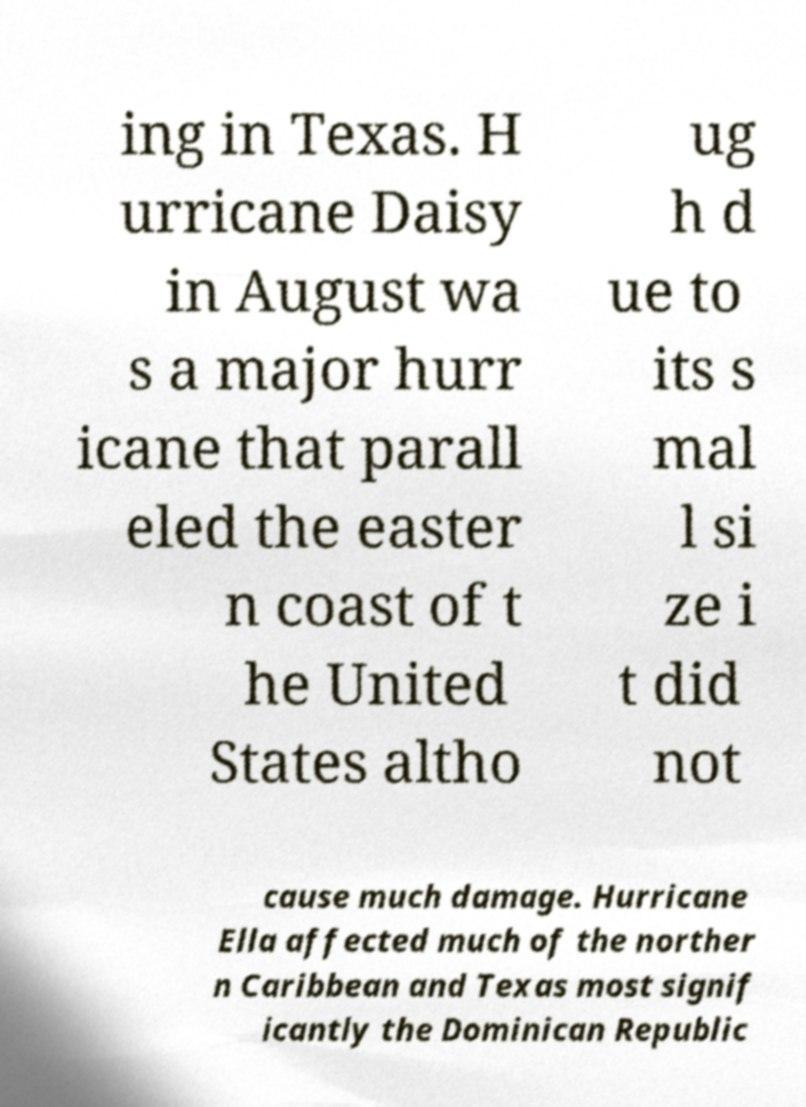There's text embedded in this image that I need extracted. Can you transcribe it verbatim? ing in Texas. H urricane Daisy in August wa s a major hurr icane that parall eled the easter n coast of t he United States altho ug h d ue to its s mal l si ze i t did not cause much damage. Hurricane Ella affected much of the norther n Caribbean and Texas most signif icantly the Dominican Republic 